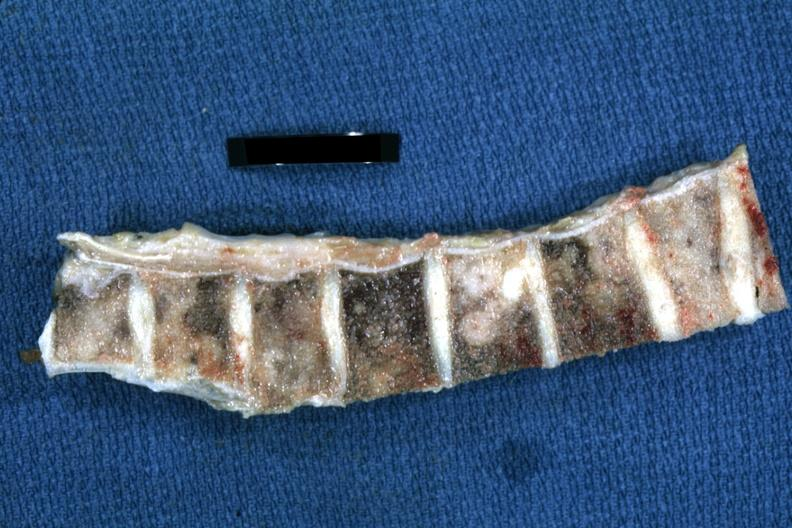what is present?
Answer the question using a single word or phrase. Joints 